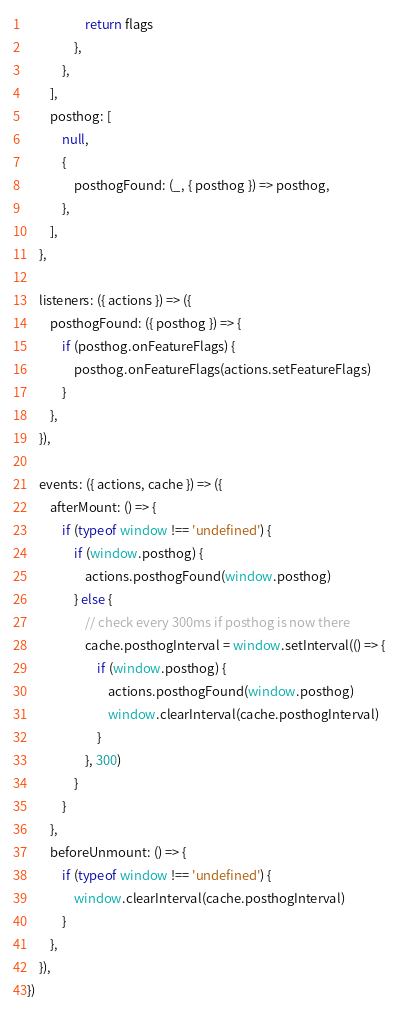<code> <loc_0><loc_0><loc_500><loc_500><_JavaScript_>                    return flags
                },
            },
        ],
        posthog: [
            null,
            {
                posthogFound: (_, { posthog }) => posthog,
            },
        ],
    },

    listeners: ({ actions }) => ({
        posthogFound: ({ posthog }) => {
            if (posthog.onFeatureFlags) {
                posthog.onFeatureFlags(actions.setFeatureFlags)
            }
        },
    }),

    events: ({ actions, cache }) => ({
        afterMount: () => {
            if (typeof window !== 'undefined') {
                if (window.posthog) {
                    actions.posthogFound(window.posthog)
                } else {
                    // check every 300ms if posthog is now there
                    cache.posthogInterval = window.setInterval(() => {
                        if (window.posthog) {
                            actions.posthogFound(window.posthog)
                            window.clearInterval(cache.posthogInterval)
                        }
                    }, 300)
                }
            }
        },
        beforeUnmount: () => {
            if (typeof window !== 'undefined') {
                window.clearInterval(cache.posthogInterval)
            }
        },
    }),
})
</code> 